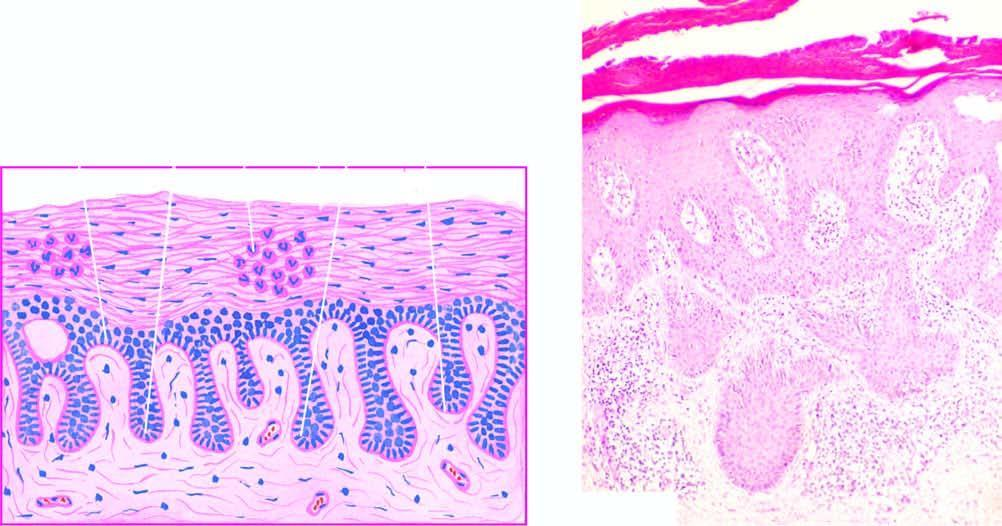what are the papillae elongated and oedematous with?
Answer the question using a single word or phrase. Suprapapillary thinning of epidermis 